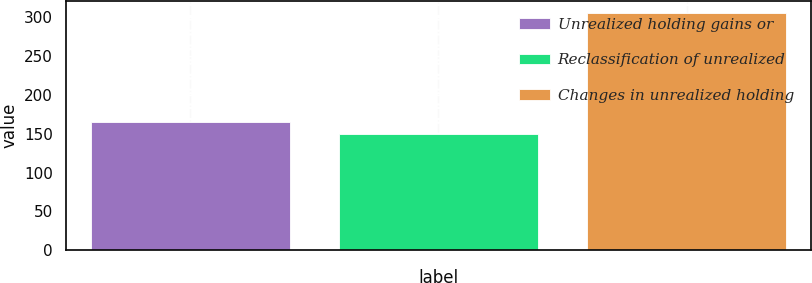Convert chart. <chart><loc_0><loc_0><loc_500><loc_500><bar_chart><fcel>Unrealized holding gains or<fcel>Reclassification of unrealized<fcel>Changes in unrealized holding<nl><fcel>164.6<fcel>149<fcel>305<nl></chart> 